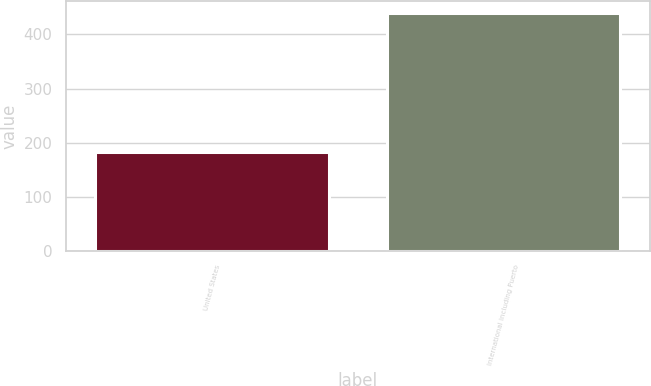Convert chart to OTSL. <chart><loc_0><loc_0><loc_500><loc_500><bar_chart><fcel>United States<fcel>International including Puerto<nl><fcel>182.8<fcel>439.6<nl></chart> 